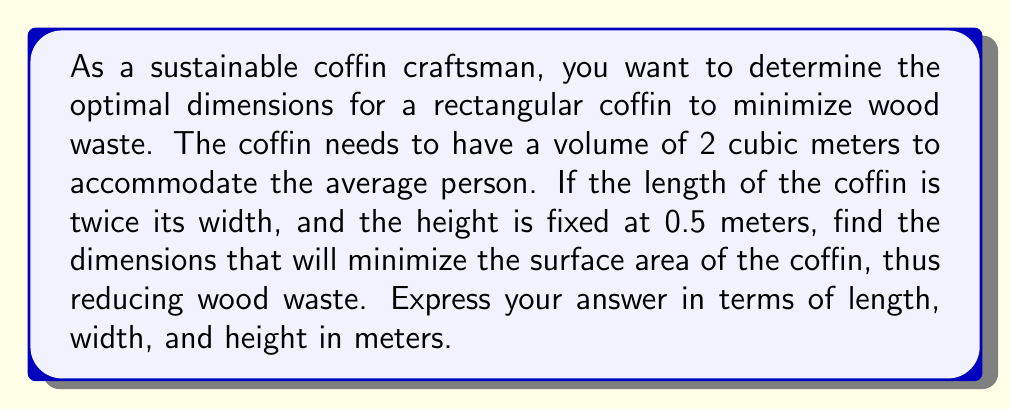Can you solve this math problem? Let's approach this step-by-step:

1) Let's define our variables:
   $w$ = width
   $l$ = length = $2w$ (given)
   $h$ = height = 0.5 m (fixed)

2) The volume of the coffin is given as 2 cubic meters:
   $V = l \times w \times h = 2w \times w \times 0.5 = w^2 = 2$

3) From this, we can express $w$ in terms of $V$:
   $w = \sqrt{2}$

4) The surface area (SA) of the coffin is what we want to minimize:
   $SA = 2(lw + lh + wh)$
   $SA = 2(2w^2 + 2w(0.5) + w(0.5))$
   $SA = 2(2w^2 + w)$

5) Substitute $w = \sqrt{2}$ into the surface area equation:
   $SA = 2(2(\sqrt{2})^2 + \sqrt{2})$
   $SA = 2(4 + \sqrt{2})$
   $SA = 8 + 2\sqrt{2}$

6) Now we can calculate the dimensions:
   Width: $w = \sqrt{2} \approx 1.414$ m
   Length: $l = 2w = 2\sqrt{2} \approx 2.828$ m
   Height: $h = 0.5$ m

These dimensions will minimize the surface area and thus the wood waste.
Answer: The optimal dimensions for the coffin are:
Length: $2\sqrt{2} \approx 2.828$ m
Width: $\sqrt{2} \approx 1.414$ m
Height: $0.5$ m 